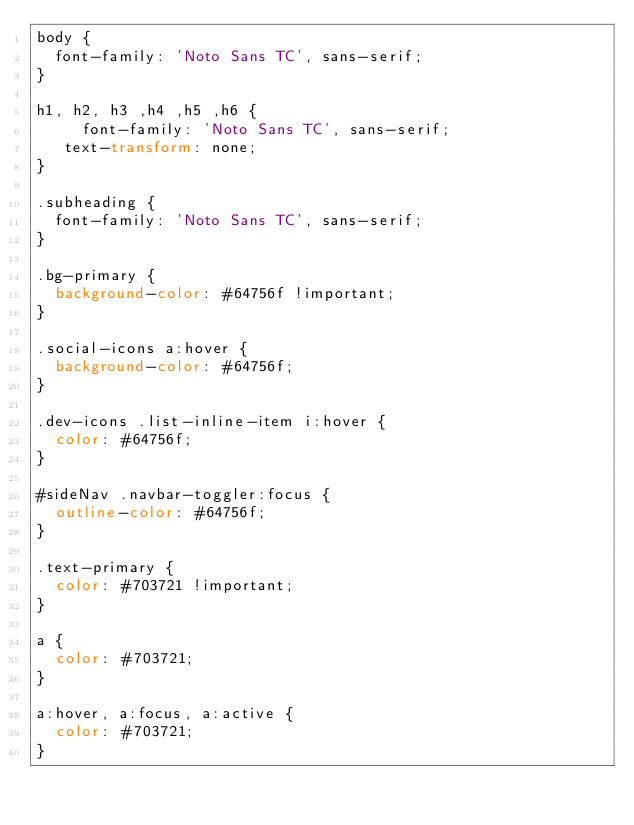<code> <loc_0><loc_0><loc_500><loc_500><_CSS_>body {
	font-family: 'Noto Sans TC', sans-serif;
}
	  
h1, h2, h3 ,h4 ,h5 ,h6 {
  	 font-family: 'Noto Sans TC', sans-serif;
	 text-transform: none;
}	 

.subheading {
	font-family: 'Noto Sans TC', sans-serif;
} 

.bg-primary {
	background-color: #64756f !important;
}

.social-icons a:hover {
  background-color: #64756f;
}

.dev-icons .list-inline-item i:hover {
  color: #64756f;
}

#sideNav .navbar-toggler:focus {
  outline-color: #64756f;
}

.text-primary {
  color: #703721 !important;
}

a {
  color: #703721;
}

a:hover, a:focus, a:active {
  color: #703721;
}</code> 